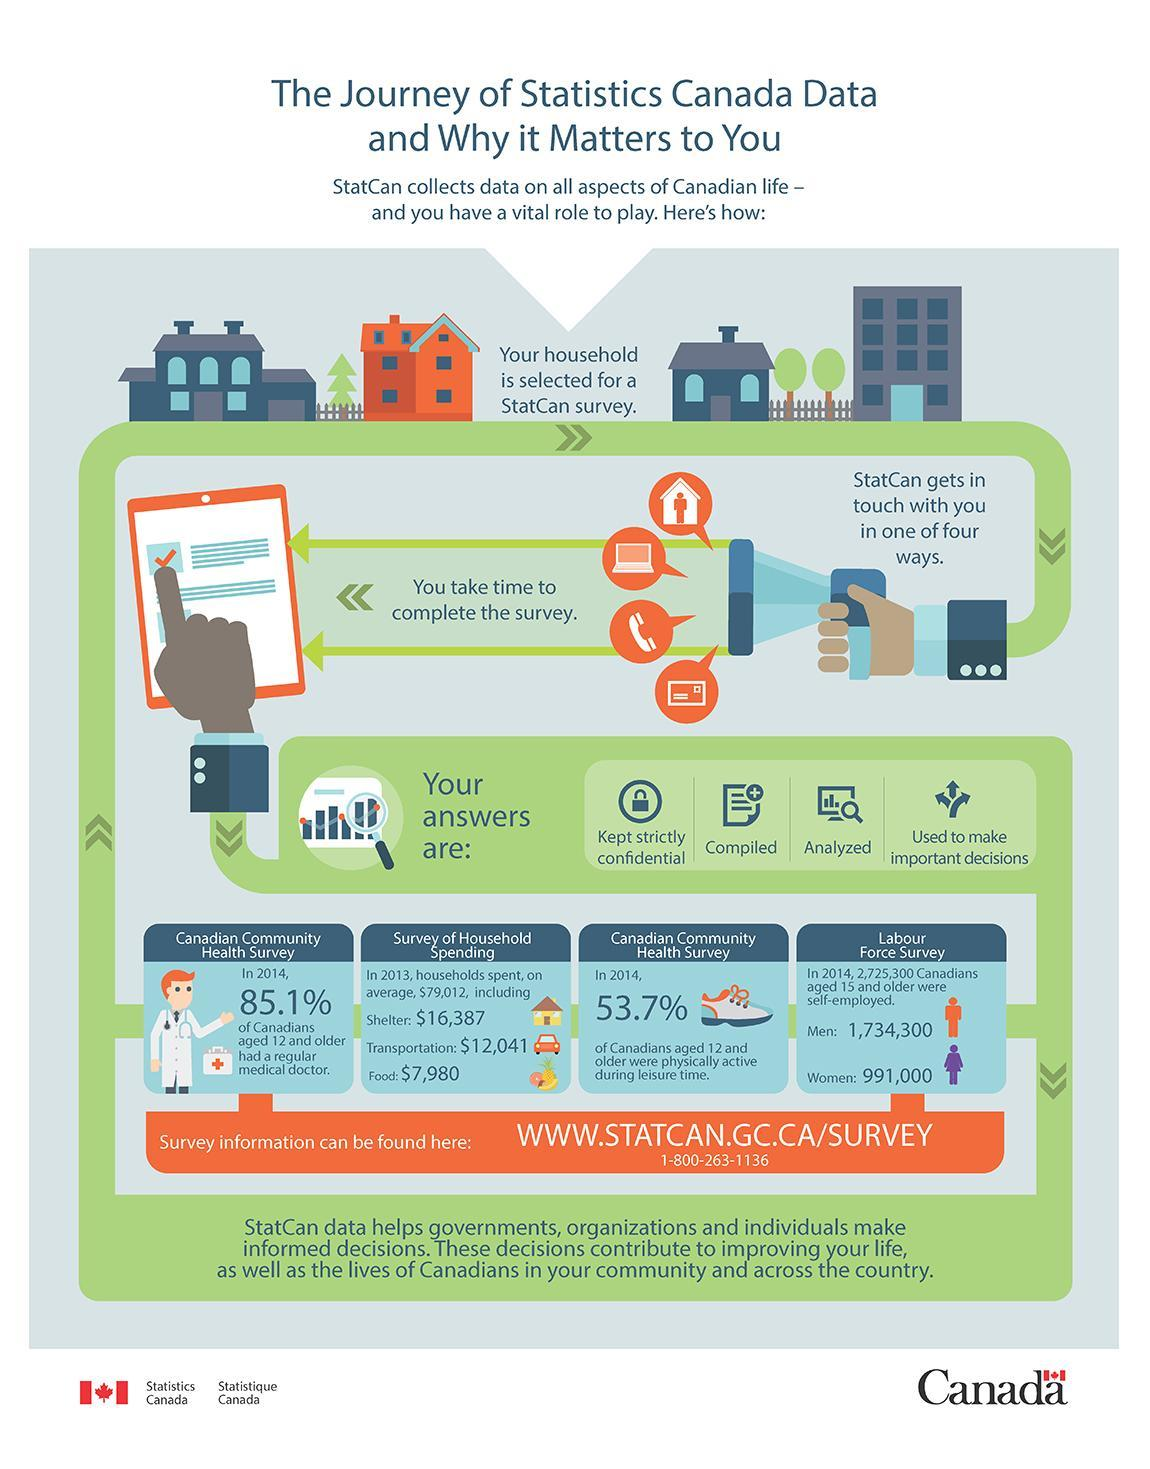How many Canadian women aged 15 years & older were self-employed according to the Labour Force Survey in 2014?
Answer the question with a short phrase. 991,000 What is the average household spent on food in Canada according to the survey of household spending in 2013? $7,980 What percentage of Canadians aged 12 & older didn't have a regular medical doctor according to the Canadian Health Survey in 2014? 14.9% 